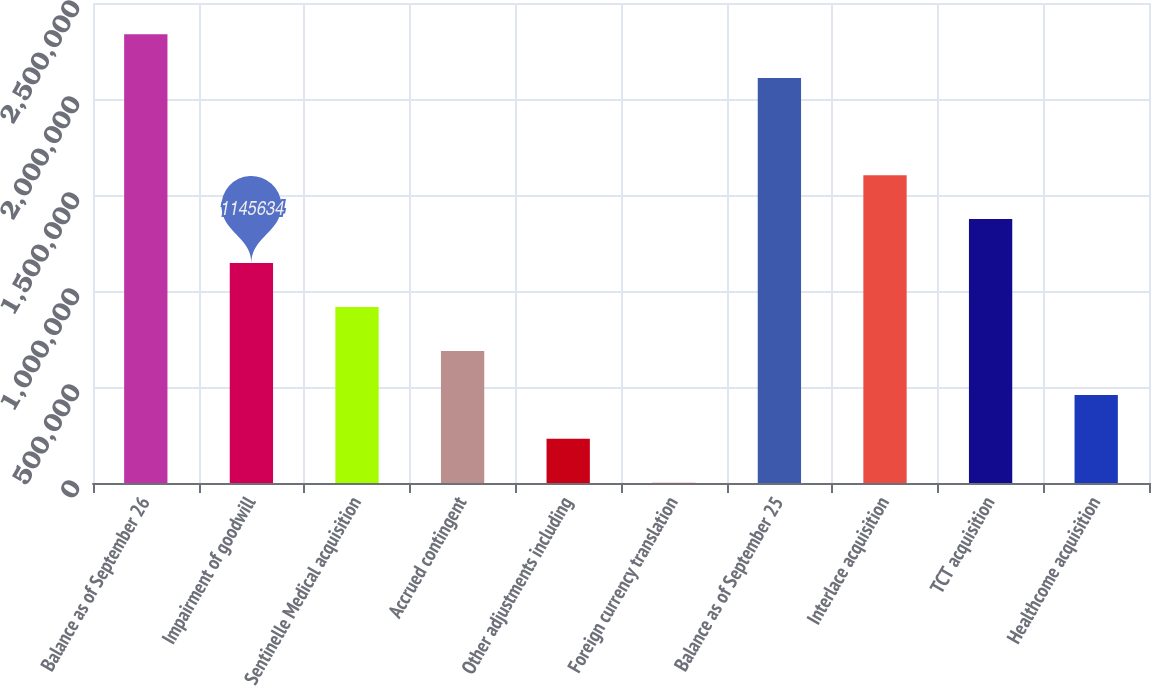<chart> <loc_0><loc_0><loc_500><loc_500><bar_chart><fcel>Balance as of September 26<fcel>Impairment of goodwill<fcel>Sentinelle Medical acquisition<fcel>Accrued contingent<fcel>Other adjustments including<fcel>Foreign currency translation<fcel>Balance as of September 25<fcel>Interlace acquisition<fcel>TCT acquisition<fcel>Healthcome acquisition<nl><fcel>2.33779e+06<fcel>1.14563e+06<fcel>916695<fcel>687756<fcel>229877<fcel>938<fcel>2.10885e+06<fcel>1.60351e+06<fcel>1.37457e+06<fcel>458816<nl></chart> 